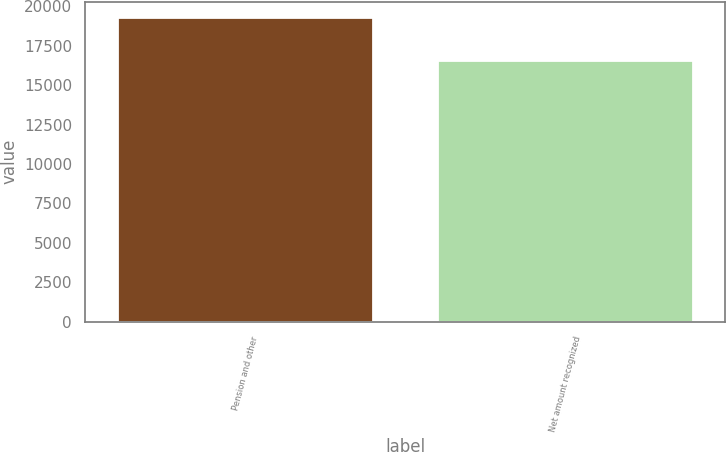Convert chart to OTSL. <chart><loc_0><loc_0><loc_500><loc_500><bar_chart><fcel>Pension and other<fcel>Net amount recognized<nl><fcel>19323<fcel>16585<nl></chart> 